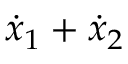<formula> <loc_0><loc_0><loc_500><loc_500>{ \dot { x } } _ { 1 } + { \dot { x } } _ { 2 }</formula> 